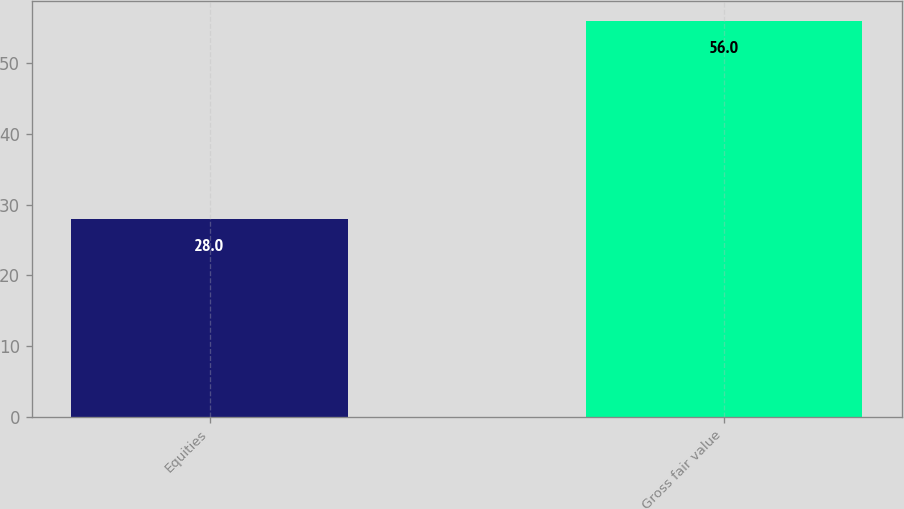Convert chart. <chart><loc_0><loc_0><loc_500><loc_500><bar_chart><fcel>Equities<fcel>Gross fair value<nl><fcel>28<fcel>56<nl></chart> 